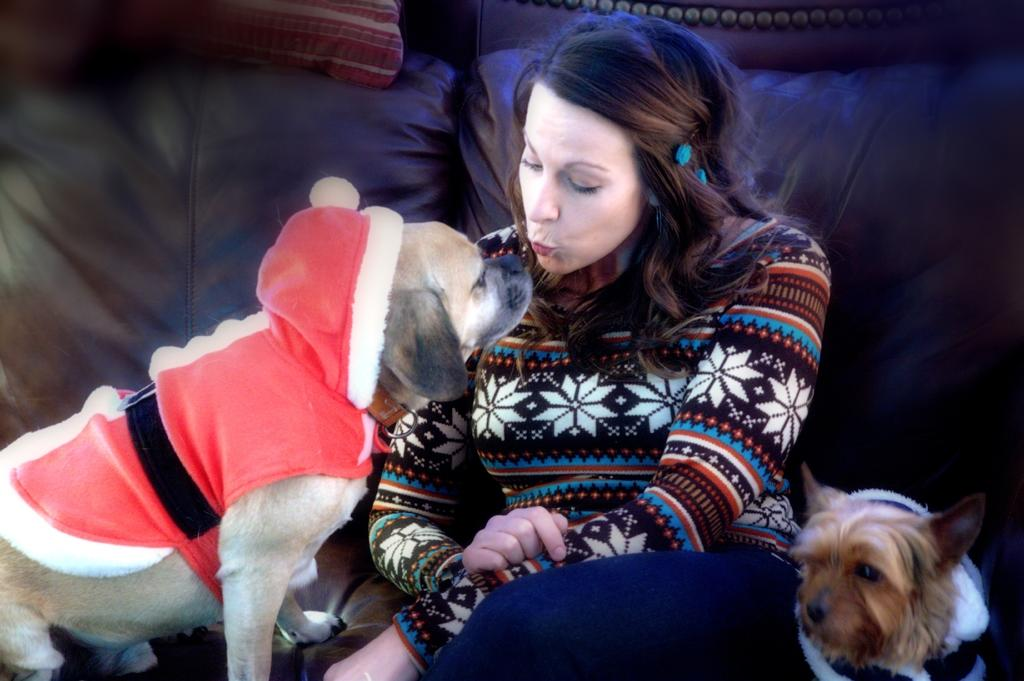Who is present in the image? There is a woman in the image. What is the woman doing in the image? The woman is on a sofa and kissing. Are there any animals in the image? Yes, there are dogs beside the woman. Can you see any cattle in the image? No, there are no cattle present in the image. Is there a maid in the image? No, there is no mention of a maid in the image. 